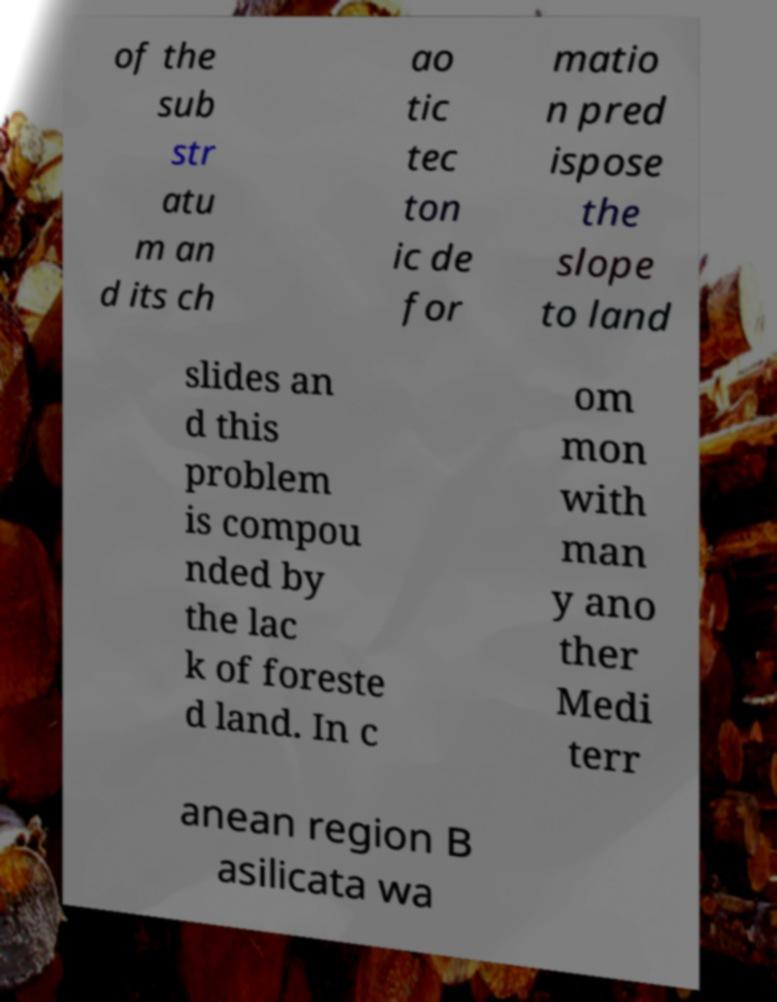Can you accurately transcribe the text from the provided image for me? of the sub str atu m an d its ch ao tic tec ton ic de for matio n pred ispose the slope to land slides an d this problem is compou nded by the lac k of foreste d land. In c om mon with man y ano ther Medi terr anean region B asilicata wa 